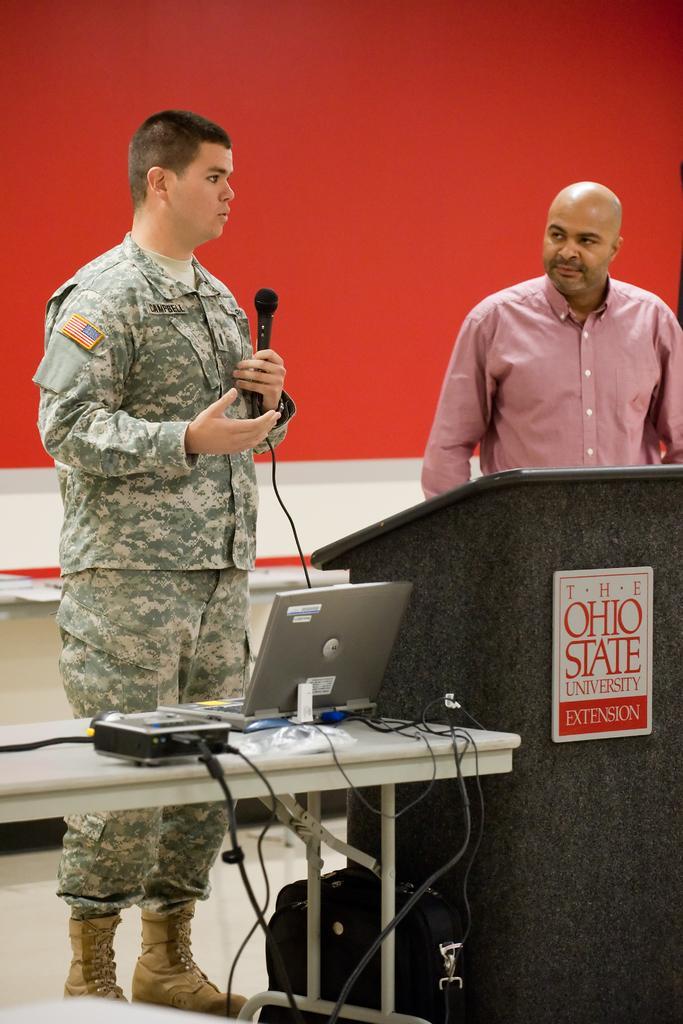In one or two sentences, can you explain what this image depicts? As we can see in the image there is a wall and two people standing over here and a table. On table there is a projector and laptop. 